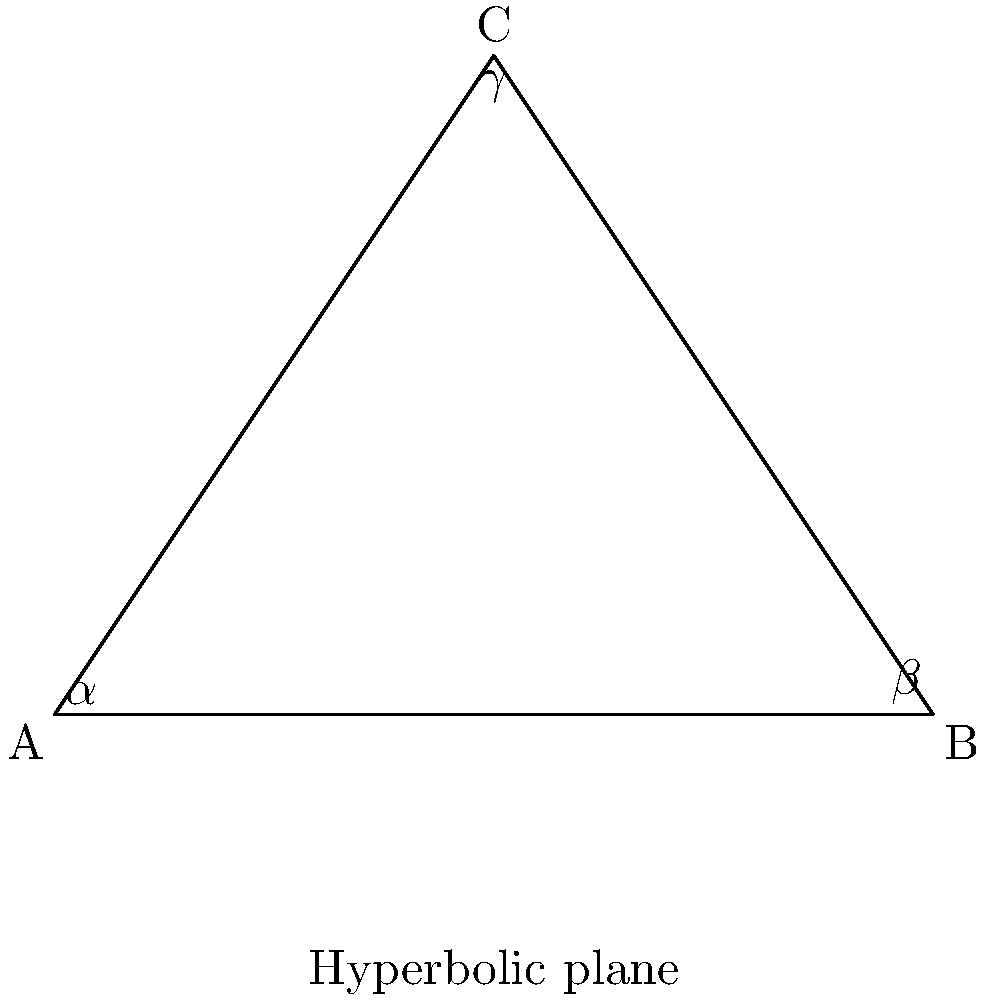In a hyperbolic plane, triangle ABC has angles $\alpha$, $\beta$, and $\gamma$. If the sum of these angles is $\frac{5\pi}{6}$, what is the area of the triangle in terms of $\pi$? Let's approach this step-by-step:

1) In Euclidean geometry, the sum of angles in a triangle is always $\pi$. However, in hyperbolic geometry, this sum is always less than $\pi$.

2) The difference between $\pi$ and the sum of the angles in a hyperbolic triangle is directly related to the area of the triangle. This relationship is given by the Gauss-Bonnet theorem.

3) For a hyperbolic triangle, the Gauss-Bonnet theorem states:

   $$\alpha + \beta + \gamma = \pi - A$$

   where $A$ is the area of the triangle.

4) In our case, we're given that $\alpha + \beta + \gamma = \frac{5\pi}{6}$

5) Substituting this into the Gauss-Bonnet formula:

   $$\frac{5\pi}{6} = \pi - A$$

6) Solving for $A$:

   $$A = \pi - \frac{5\pi}{6} = \frac{\pi}{6}$$

Therefore, the area of the triangle is $\frac{\pi}{6}$.
Answer: $\frac{\pi}{6}$ 